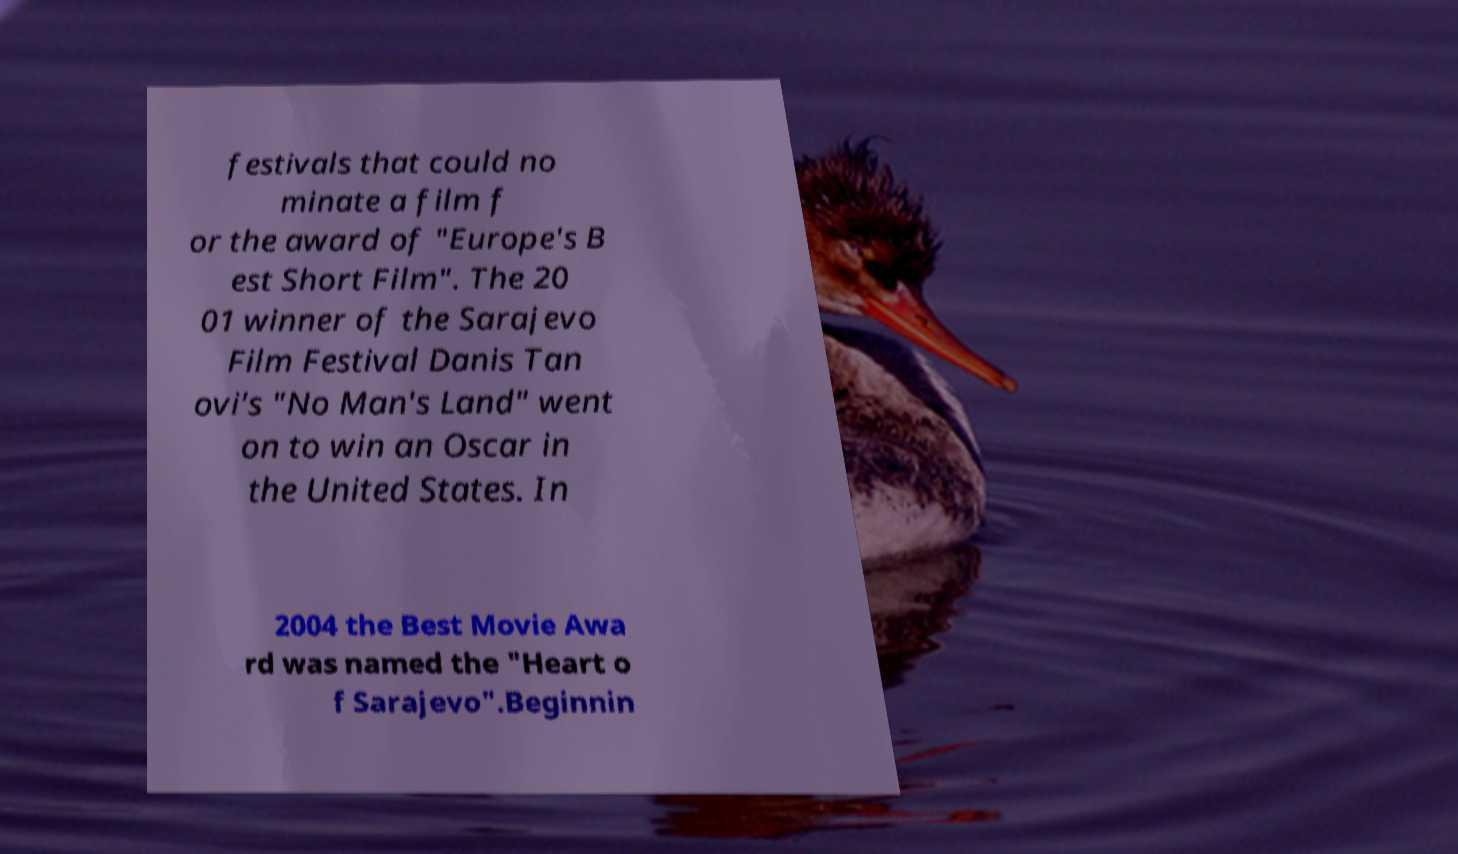Please read and relay the text visible in this image. What does it say? festivals that could no minate a film f or the award of "Europe's B est Short Film". The 20 01 winner of the Sarajevo Film Festival Danis Tan ovi's "No Man's Land" went on to win an Oscar in the United States. In 2004 the Best Movie Awa rd was named the "Heart o f Sarajevo".Beginnin 